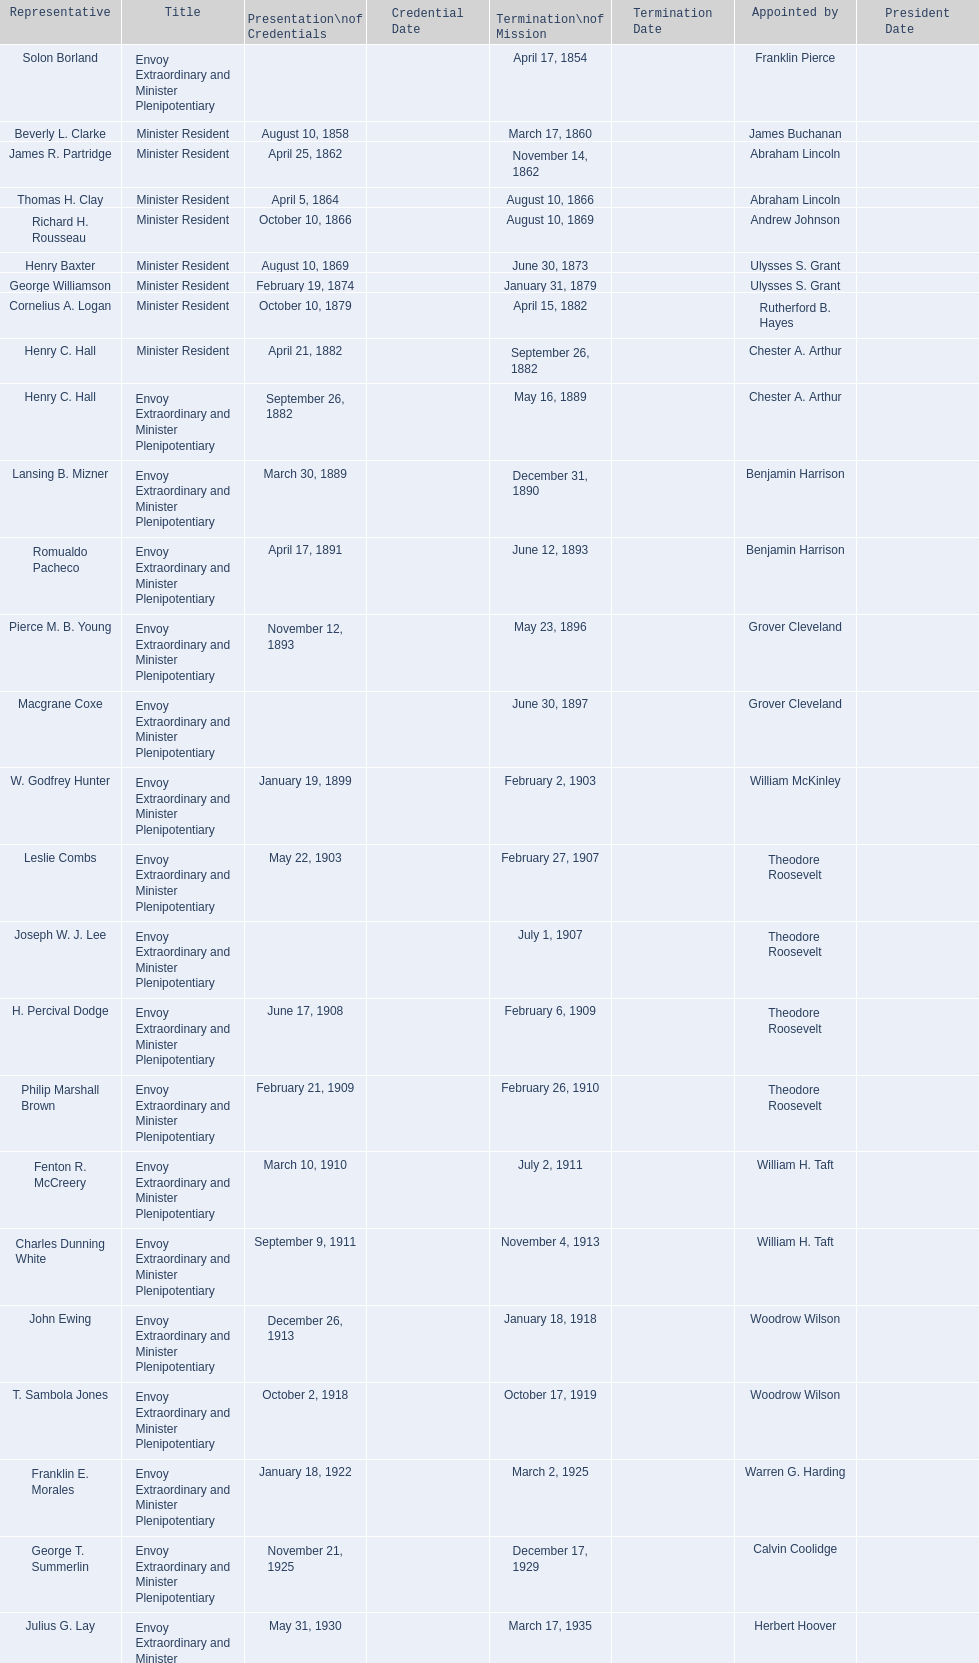How many representatives were appointed by theodore roosevelt? 4. 